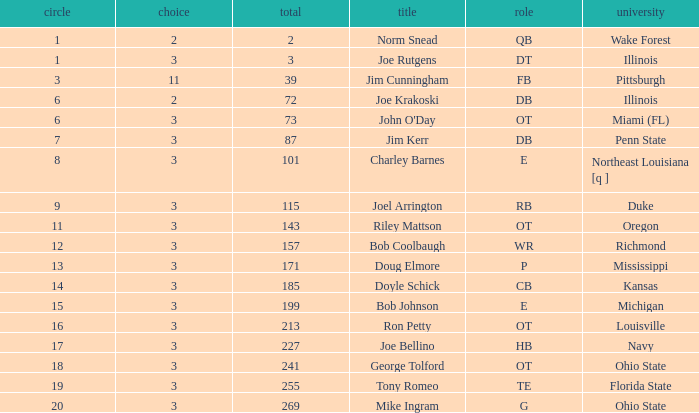How many rounds have john o'day as the name, and a pick less than 3? None. 